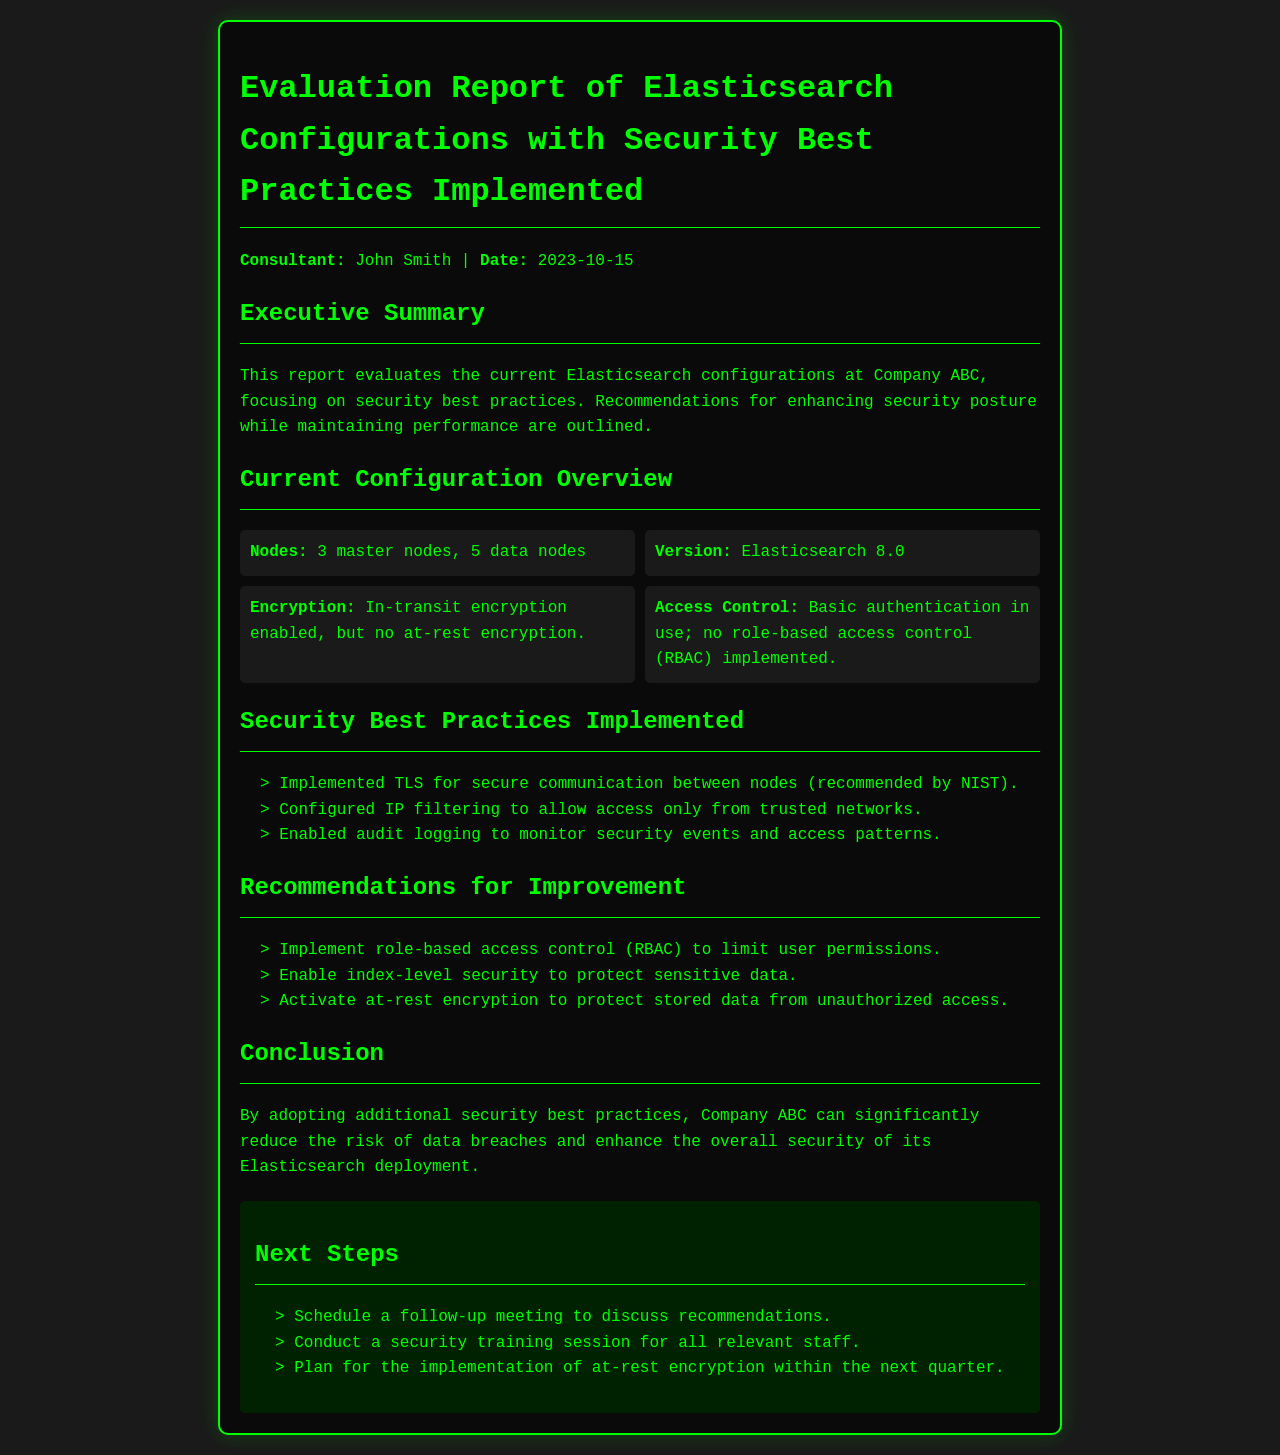What is the date of the report? The date of the report is mentioned in the consultant information section.
Answer: 2023-10-15 How many data nodes are there? The number of data nodes is specified under the current configuration overview.
Answer: 5 data nodes What security feature is currently not implemented? The recommended security feature that is not implemented is listed in the recommendations for improvement section.
Answer: Role-based access control Which encryption type is enabled? The type of encryption currently enabled is specified in the configuration overview.
Answer: In-transit encryption What should be activated to protect stored data? The action to protect stored data is outlined in the recommendations for improvement section.
Answer: At-rest encryption Who is the consultant? The name of the consultant is mentioned at the beginning of the report.
Answer: John Smith What was configured to restrict access? The measure to restrict access is described in the section on security best practices.
Answer: IP filtering How many master nodes are there? The number of master nodes is provided in the current configuration overview.
Answer: 3 master nodes What is the title of the report? The title of the report is indicated at the top of the document.
Answer: Evaluation Report of Elasticsearch Configurations with Security Best Practices Implemented 